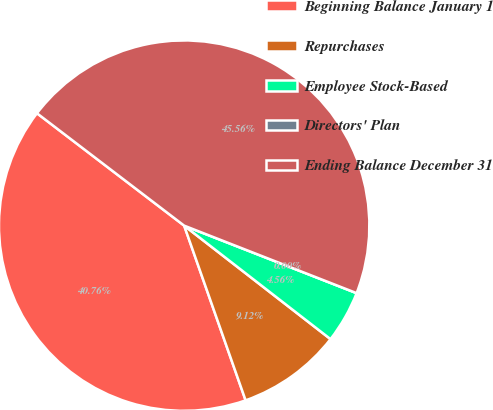Convert chart to OTSL. <chart><loc_0><loc_0><loc_500><loc_500><pie_chart><fcel>Beginning Balance January 1<fcel>Repurchases<fcel>Employee Stock-Based<fcel>Directors' Plan<fcel>Ending Balance December 31<nl><fcel>40.76%<fcel>9.12%<fcel>4.56%<fcel>0.0%<fcel>45.56%<nl></chart> 